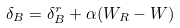Convert formula to latex. <formula><loc_0><loc_0><loc_500><loc_500>\delta _ { B } = \delta _ { B } ^ { r } + \alpha ( W _ { R } - W )</formula> 